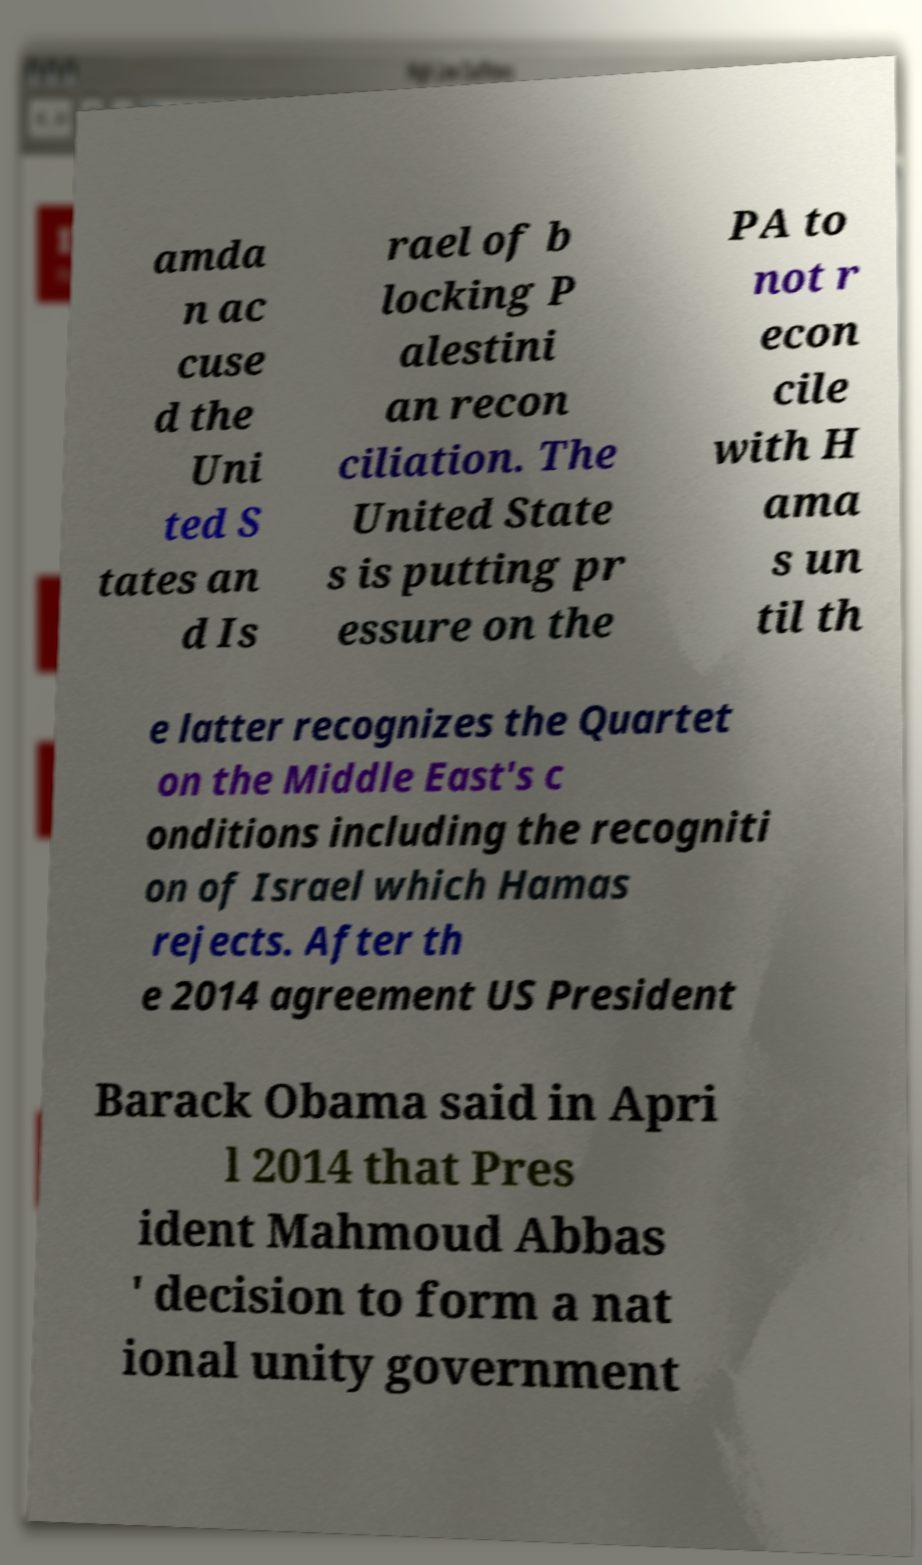There's text embedded in this image that I need extracted. Can you transcribe it verbatim? amda n ac cuse d the Uni ted S tates an d Is rael of b locking P alestini an recon ciliation. The United State s is putting pr essure on the PA to not r econ cile with H ama s un til th e latter recognizes the Quartet on the Middle East's c onditions including the recogniti on of Israel which Hamas rejects. After th e 2014 agreement US President Barack Obama said in Apri l 2014 that Pres ident Mahmoud Abbas ' decision to form a nat ional unity government 